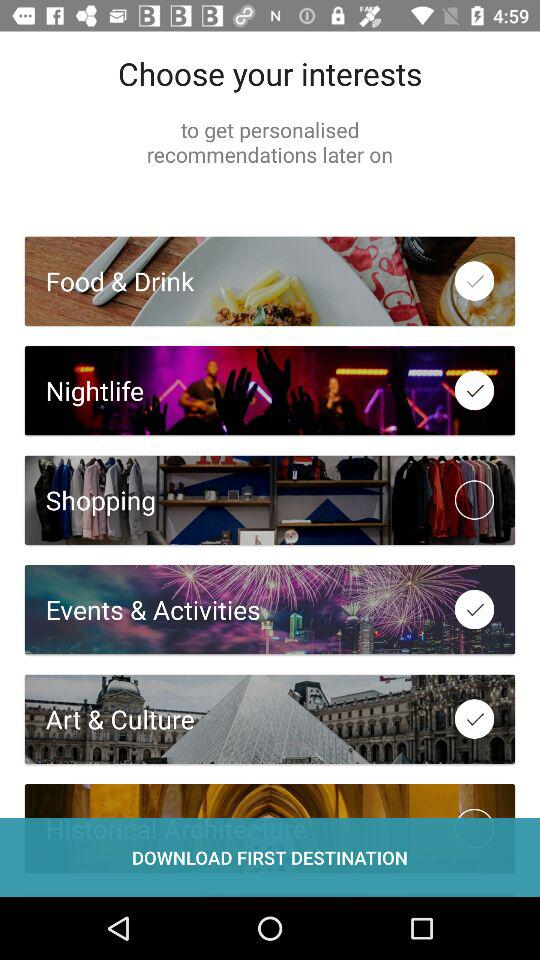What is the status of "Shopping"? The status is "off". 